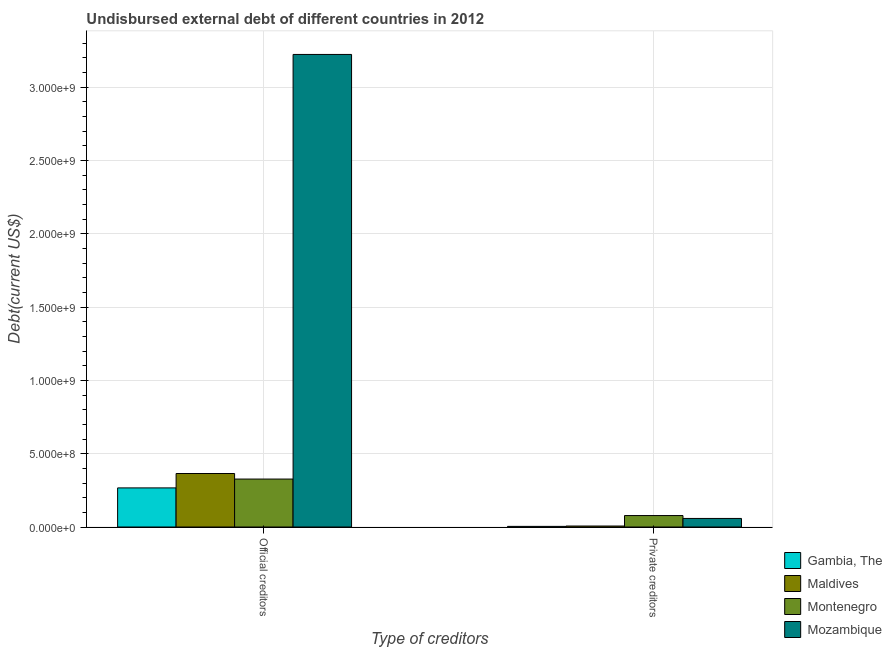How many different coloured bars are there?
Your answer should be very brief. 4. How many groups of bars are there?
Ensure brevity in your answer.  2. How many bars are there on the 2nd tick from the left?
Offer a very short reply. 4. What is the label of the 2nd group of bars from the left?
Provide a short and direct response. Private creditors. What is the undisbursed external debt of private creditors in Mozambique?
Provide a succinct answer. 5.84e+07. Across all countries, what is the maximum undisbursed external debt of private creditors?
Give a very brief answer. 7.82e+07. Across all countries, what is the minimum undisbursed external debt of private creditors?
Your answer should be compact. 4.34e+06. In which country was the undisbursed external debt of private creditors maximum?
Keep it short and to the point. Montenegro. In which country was the undisbursed external debt of private creditors minimum?
Your response must be concise. Gambia, The. What is the total undisbursed external debt of official creditors in the graph?
Offer a very short reply. 4.18e+09. What is the difference between the undisbursed external debt of official creditors in Mozambique and that in Maldives?
Your response must be concise. 2.86e+09. What is the difference between the undisbursed external debt of official creditors in Maldives and the undisbursed external debt of private creditors in Montenegro?
Ensure brevity in your answer.  2.87e+08. What is the average undisbursed external debt of private creditors per country?
Provide a short and direct response. 3.69e+07. What is the difference between the undisbursed external debt of official creditors and undisbursed external debt of private creditors in Montenegro?
Ensure brevity in your answer.  2.49e+08. In how many countries, is the undisbursed external debt of private creditors greater than 400000000 US$?
Your answer should be compact. 0. What is the ratio of the undisbursed external debt of official creditors in Mozambique to that in Gambia, The?
Your answer should be compact. 12.08. Is the undisbursed external debt of official creditors in Gambia, The less than that in Mozambique?
Offer a terse response. Yes. What does the 2nd bar from the left in Official creditors represents?
Provide a short and direct response. Maldives. What does the 3rd bar from the right in Private creditors represents?
Your answer should be compact. Maldives. How many bars are there?
Provide a short and direct response. 8. How many countries are there in the graph?
Your response must be concise. 4. What is the difference between two consecutive major ticks on the Y-axis?
Offer a terse response. 5.00e+08. Are the values on the major ticks of Y-axis written in scientific E-notation?
Give a very brief answer. Yes. Does the graph contain any zero values?
Give a very brief answer. No. How are the legend labels stacked?
Give a very brief answer. Vertical. What is the title of the graph?
Give a very brief answer. Undisbursed external debt of different countries in 2012. Does "Suriname" appear as one of the legend labels in the graph?
Offer a very short reply. No. What is the label or title of the X-axis?
Make the answer very short. Type of creditors. What is the label or title of the Y-axis?
Offer a terse response. Debt(current US$). What is the Debt(current US$) of Gambia, The in Official creditors?
Offer a very short reply. 2.67e+08. What is the Debt(current US$) in Maldives in Official creditors?
Offer a terse response. 3.65e+08. What is the Debt(current US$) in Montenegro in Official creditors?
Keep it short and to the point. 3.27e+08. What is the Debt(current US$) in Mozambique in Official creditors?
Your response must be concise. 3.22e+09. What is the Debt(current US$) of Gambia, The in Private creditors?
Keep it short and to the point. 4.34e+06. What is the Debt(current US$) of Maldives in Private creditors?
Provide a short and direct response. 6.80e+06. What is the Debt(current US$) in Montenegro in Private creditors?
Provide a succinct answer. 7.82e+07. What is the Debt(current US$) of Mozambique in Private creditors?
Provide a short and direct response. 5.84e+07. Across all Type of creditors, what is the maximum Debt(current US$) of Gambia, The?
Provide a short and direct response. 2.67e+08. Across all Type of creditors, what is the maximum Debt(current US$) in Maldives?
Provide a succinct answer. 3.65e+08. Across all Type of creditors, what is the maximum Debt(current US$) of Montenegro?
Your response must be concise. 3.27e+08. Across all Type of creditors, what is the maximum Debt(current US$) of Mozambique?
Ensure brevity in your answer.  3.22e+09. Across all Type of creditors, what is the minimum Debt(current US$) of Gambia, The?
Give a very brief answer. 4.34e+06. Across all Type of creditors, what is the minimum Debt(current US$) of Maldives?
Offer a very short reply. 6.80e+06. Across all Type of creditors, what is the minimum Debt(current US$) of Montenegro?
Give a very brief answer. 7.82e+07. Across all Type of creditors, what is the minimum Debt(current US$) in Mozambique?
Your response must be concise. 5.84e+07. What is the total Debt(current US$) in Gambia, The in the graph?
Offer a terse response. 2.71e+08. What is the total Debt(current US$) of Maldives in the graph?
Make the answer very short. 3.72e+08. What is the total Debt(current US$) in Montenegro in the graph?
Offer a very short reply. 4.05e+08. What is the total Debt(current US$) in Mozambique in the graph?
Your answer should be compact. 3.28e+09. What is the difference between the Debt(current US$) in Gambia, The in Official creditors and that in Private creditors?
Give a very brief answer. 2.62e+08. What is the difference between the Debt(current US$) in Maldives in Official creditors and that in Private creditors?
Your answer should be very brief. 3.58e+08. What is the difference between the Debt(current US$) of Montenegro in Official creditors and that in Private creditors?
Make the answer very short. 2.49e+08. What is the difference between the Debt(current US$) of Mozambique in Official creditors and that in Private creditors?
Make the answer very short. 3.16e+09. What is the difference between the Debt(current US$) of Gambia, The in Official creditors and the Debt(current US$) of Maldives in Private creditors?
Your response must be concise. 2.60e+08. What is the difference between the Debt(current US$) of Gambia, The in Official creditors and the Debt(current US$) of Montenegro in Private creditors?
Give a very brief answer. 1.89e+08. What is the difference between the Debt(current US$) of Gambia, The in Official creditors and the Debt(current US$) of Mozambique in Private creditors?
Make the answer very short. 2.08e+08. What is the difference between the Debt(current US$) of Maldives in Official creditors and the Debt(current US$) of Montenegro in Private creditors?
Offer a terse response. 2.87e+08. What is the difference between the Debt(current US$) of Maldives in Official creditors and the Debt(current US$) of Mozambique in Private creditors?
Keep it short and to the point. 3.07e+08. What is the difference between the Debt(current US$) of Montenegro in Official creditors and the Debt(current US$) of Mozambique in Private creditors?
Give a very brief answer. 2.69e+08. What is the average Debt(current US$) in Gambia, The per Type of creditors?
Provide a short and direct response. 1.36e+08. What is the average Debt(current US$) in Maldives per Type of creditors?
Ensure brevity in your answer.  1.86e+08. What is the average Debt(current US$) of Montenegro per Type of creditors?
Offer a very short reply. 2.03e+08. What is the average Debt(current US$) in Mozambique per Type of creditors?
Your answer should be compact. 1.64e+09. What is the difference between the Debt(current US$) in Gambia, The and Debt(current US$) in Maldives in Official creditors?
Your answer should be compact. -9.82e+07. What is the difference between the Debt(current US$) in Gambia, The and Debt(current US$) in Montenegro in Official creditors?
Offer a terse response. -6.04e+07. What is the difference between the Debt(current US$) in Gambia, The and Debt(current US$) in Mozambique in Official creditors?
Your answer should be very brief. -2.96e+09. What is the difference between the Debt(current US$) of Maldives and Debt(current US$) of Montenegro in Official creditors?
Provide a short and direct response. 3.78e+07. What is the difference between the Debt(current US$) of Maldives and Debt(current US$) of Mozambique in Official creditors?
Your response must be concise. -2.86e+09. What is the difference between the Debt(current US$) in Montenegro and Debt(current US$) in Mozambique in Official creditors?
Your answer should be very brief. -2.90e+09. What is the difference between the Debt(current US$) in Gambia, The and Debt(current US$) in Maldives in Private creditors?
Make the answer very short. -2.46e+06. What is the difference between the Debt(current US$) of Gambia, The and Debt(current US$) of Montenegro in Private creditors?
Your answer should be very brief. -7.38e+07. What is the difference between the Debt(current US$) of Gambia, The and Debt(current US$) of Mozambique in Private creditors?
Give a very brief answer. -5.41e+07. What is the difference between the Debt(current US$) in Maldives and Debt(current US$) in Montenegro in Private creditors?
Provide a succinct answer. -7.14e+07. What is the difference between the Debt(current US$) of Maldives and Debt(current US$) of Mozambique in Private creditors?
Make the answer very short. -5.16e+07. What is the difference between the Debt(current US$) in Montenegro and Debt(current US$) in Mozambique in Private creditors?
Your response must be concise. 1.97e+07. What is the ratio of the Debt(current US$) of Gambia, The in Official creditors to that in Private creditors?
Your answer should be compact. 61.49. What is the ratio of the Debt(current US$) of Maldives in Official creditors to that in Private creditors?
Provide a short and direct response. 53.71. What is the ratio of the Debt(current US$) of Montenegro in Official creditors to that in Private creditors?
Your answer should be very brief. 4.18. What is the ratio of the Debt(current US$) of Mozambique in Official creditors to that in Private creditors?
Offer a very short reply. 55.15. What is the difference between the highest and the second highest Debt(current US$) of Gambia, The?
Your answer should be compact. 2.62e+08. What is the difference between the highest and the second highest Debt(current US$) in Maldives?
Provide a short and direct response. 3.58e+08. What is the difference between the highest and the second highest Debt(current US$) in Montenegro?
Your response must be concise. 2.49e+08. What is the difference between the highest and the second highest Debt(current US$) of Mozambique?
Provide a short and direct response. 3.16e+09. What is the difference between the highest and the lowest Debt(current US$) of Gambia, The?
Provide a short and direct response. 2.62e+08. What is the difference between the highest and the lowest Debt(current US$) of Maldives?
Your response must be concise. 3.58e+08. What is the difference between the highest and the lowest Debt(current US$) in Montenegro?
Offer a terse response. 2.49e+08. What is the difference between the highest and the lowest Debt(current US$) in Mozambique?
Your answer should be very brief. 3.16e+09. 